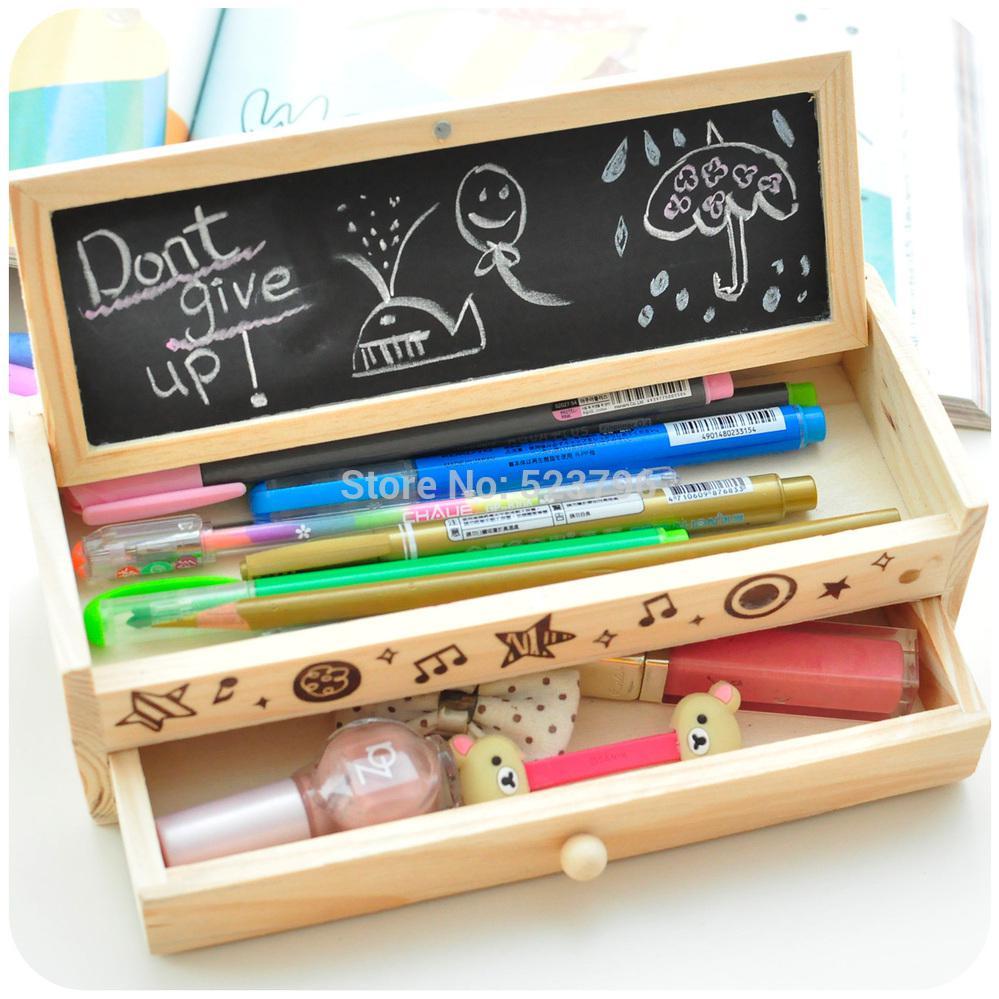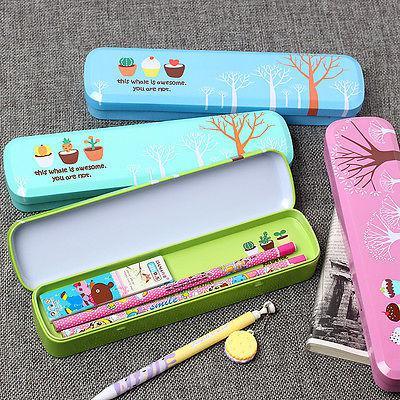The first image is the image on the left, the second image is the image on the right. Considering the images on both sides, is "In one image, a wooden pencil case has a drawer pulled out to reveal stowed items and the top raised to show writing tools and a small blackboard with writing on it." valid? Answer yes or no. Yes. The first image is the image on the left, the second image is the image on the right. For the images displayed, is the sentence "An image shows solid-color blue, pink, yellow and aqua zipper pencil cases, with three of them in a single row." factually correct? Answer yes or no. No. 